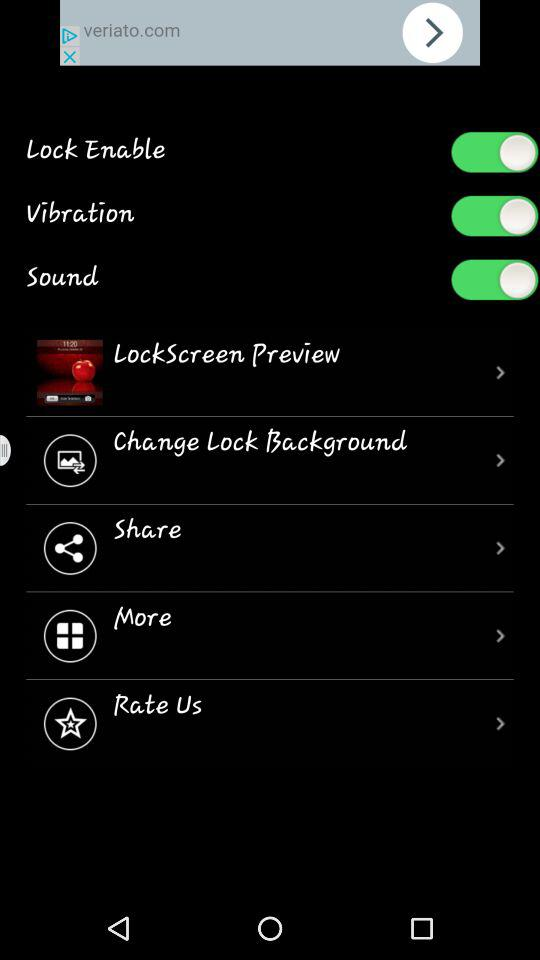What is the time? The time is 10:29. 